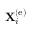<formula> <loc_0><loc_0><loc_500><loc_500>{ X } _ { i } ^ { \left ( e \right ) }</formula> 